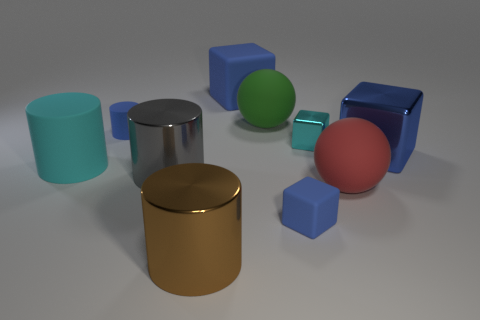Is the number of blue objects to the left of the large brown metallic cylinder greater than the number of small cyan metallic cylinders?
Provide a succinct answer. Yes. What material is the large gray cylinder?
Provide a short and direct response. Metal. There is a gray object that is made of the same material as the large brown cylinder; what is its shape?
Make the answer very short. Cylinder. There is a cyan cylinder that is behind the big shiny cylinder in front of the big gray object; what size is it?
Keep it short and to the point. Large. There is a large rubber sphere in front of the green rubber sphere; what color is it?
Offer a terse response. Red. Are there any green objects of the same shape as the large gray object?
Provide a succinct answer. No. Are there fewer big rubber cylinders that are on the right side of the red ball than big cubes that are right of the green matte sphere?
Keep it short and to the point. Yes. The big rubber block is what color?
Make the answer very short. Blue. There is a blue rubber block behind the big green object; is there a large gray metal thing that is behind it?
Your answer should be compact. No. How many blue rubber objects are the same size as the cyan cylinder?
Ensure brevity in your answer.  1. 